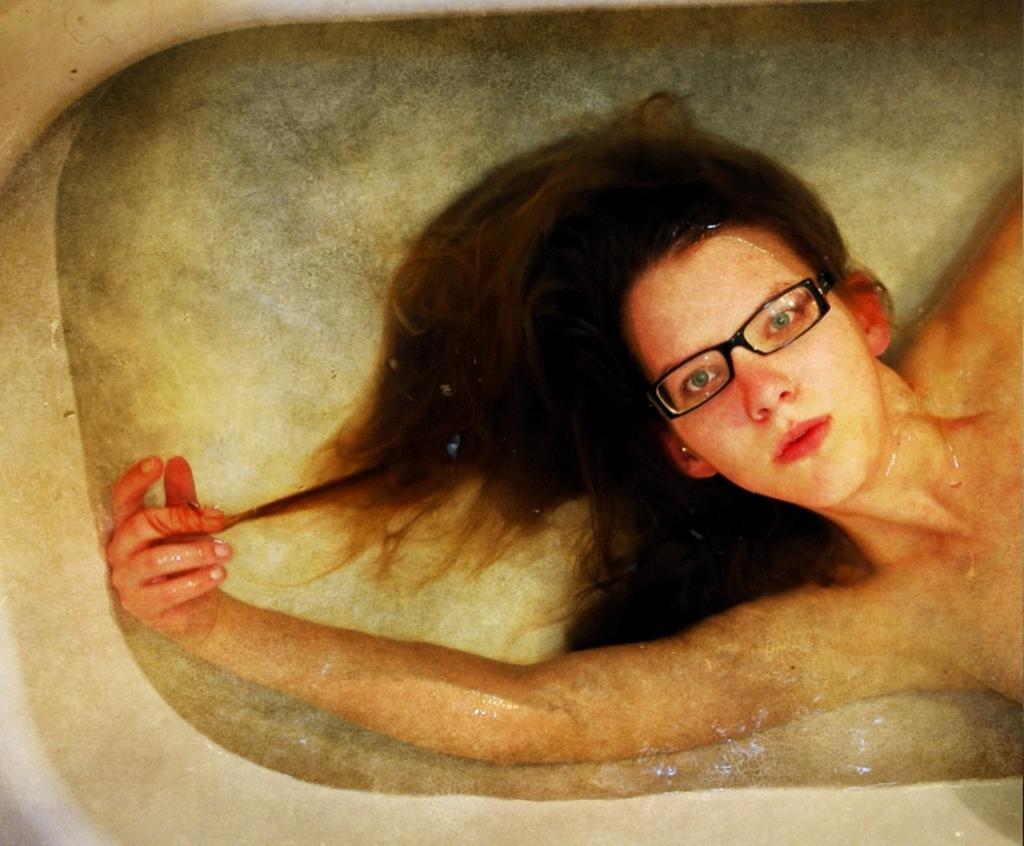Can you describe this image briefly? In the white tub, we can see a woman in water wearing glasses and seeing. 